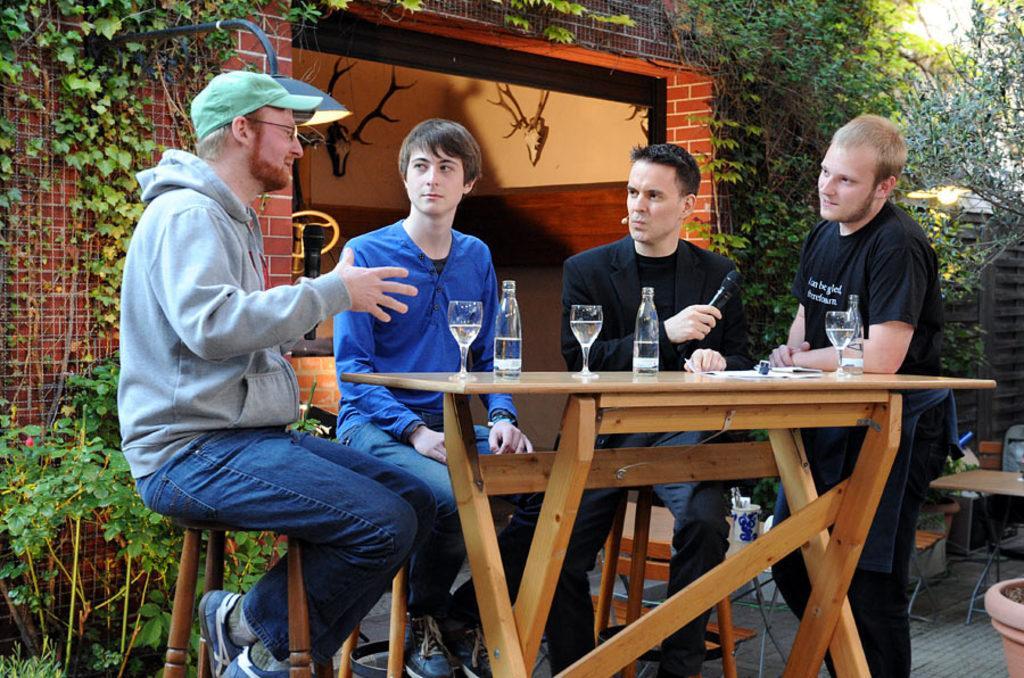In one or two sentences, can you explain what this image depicts? In this picture there are four men. Three are sitting and one man is standing. There is a bottle,glass on the table. There are few plants and a flower pot. There is a light. 